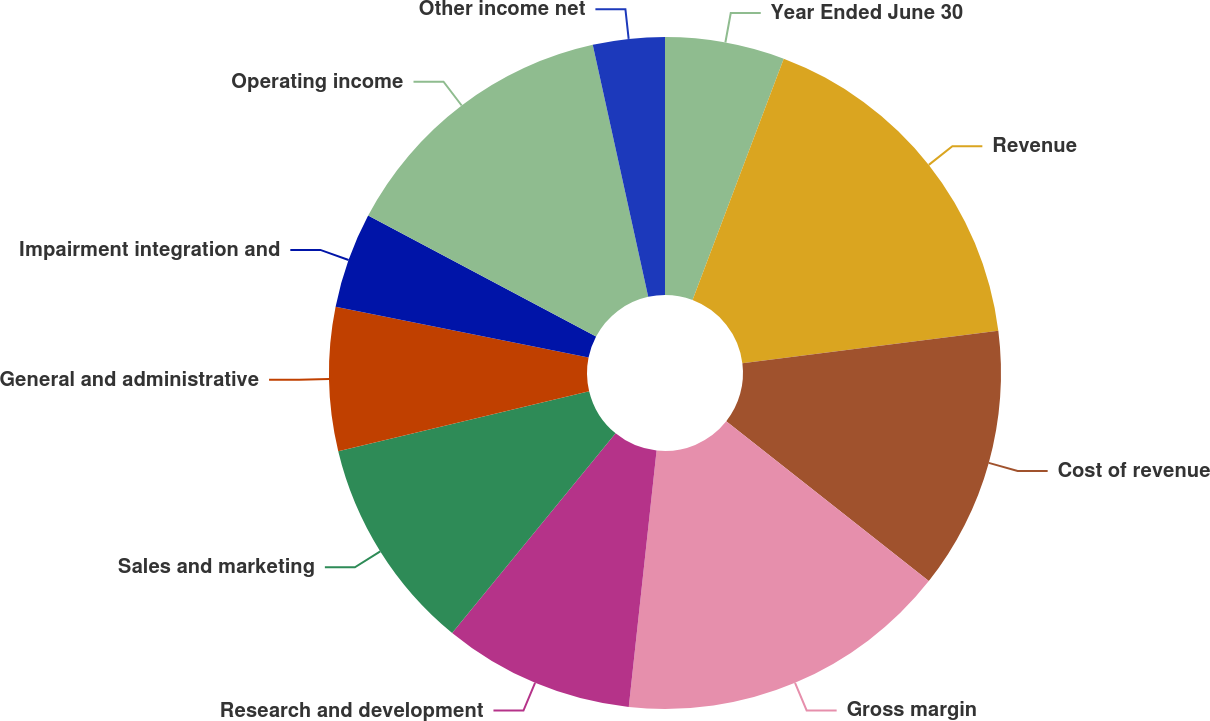Convert chart. <chart><loc_0><loc_0><loc_500><loc_500><pie_chart><fcel>Year Ended June 30<fcel>Revenue<fcel>Cost of revenue<fcel>Gross margin<fcel>Research and development<fcel>Sales and marketing<fcel>General and administrative<fcel>Impairment integration and<fcel>Operating income<fcel>Other income net<nl><fcel>5.75%<fcel>17.24%<fcel>12.64%<fcel>16.09%<fcel>9.2%<fcel>10.34%<fcel>6.9%<fcel>4.6%<fcel>13.79%<fcel>3.45%<nl></chart> 